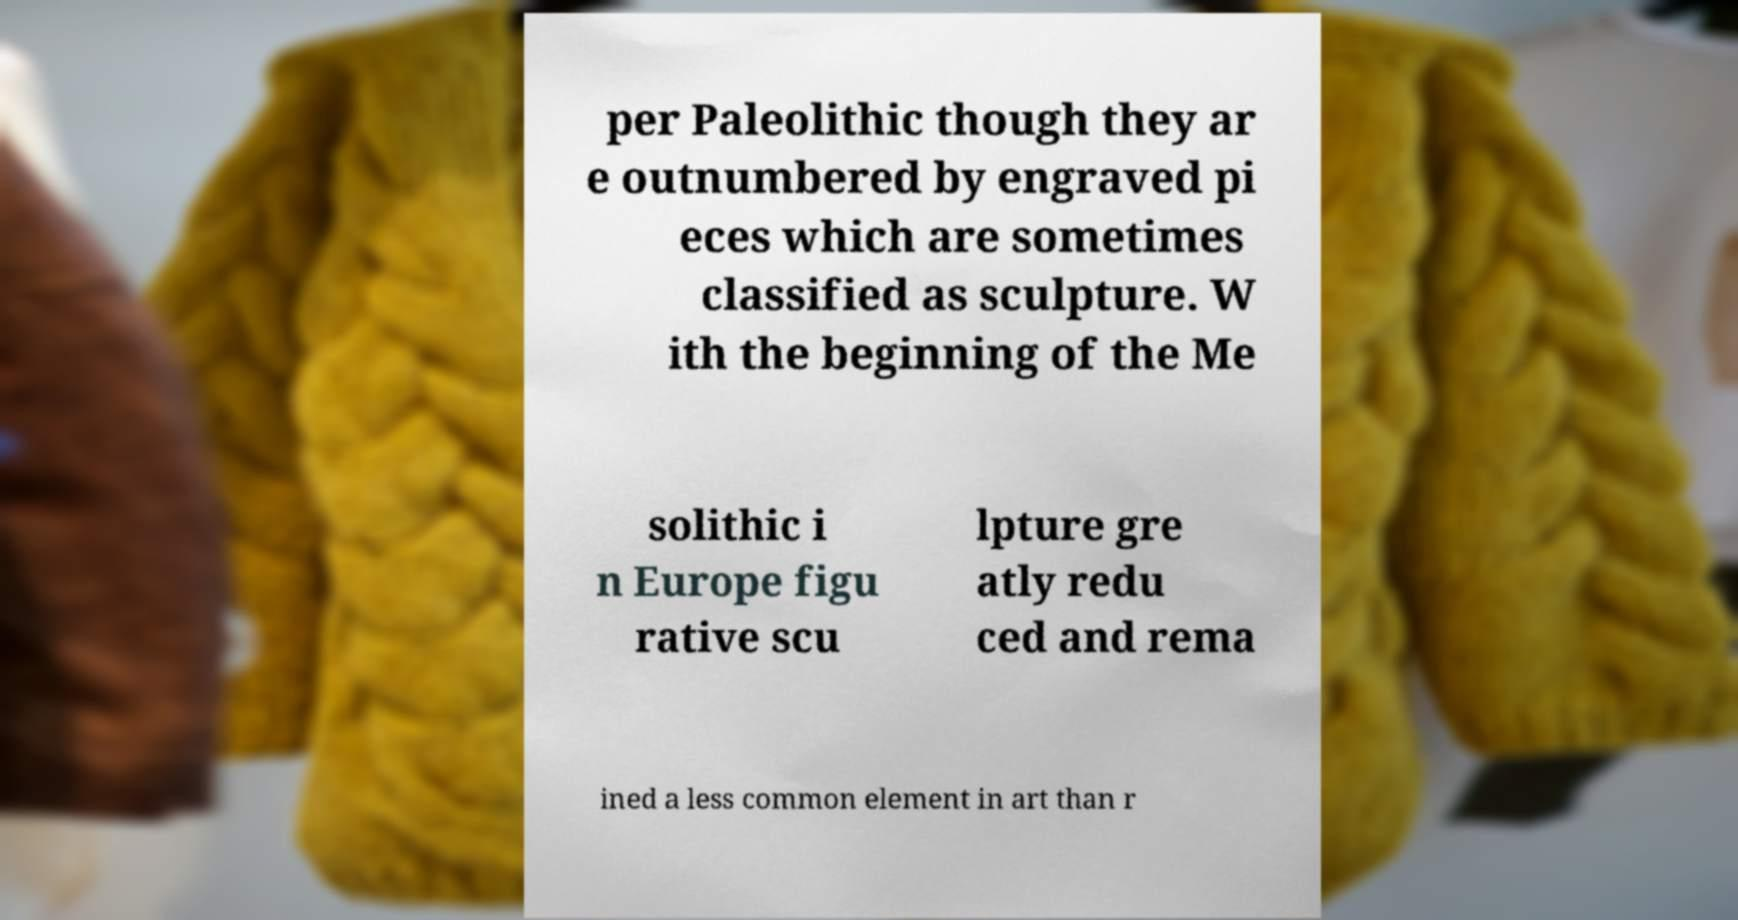Could you extract and type out the text from this image? per Paleolithic though they ar e outnumbered by engraved pi eces which are sometimes classified as sculpture. W ith the beginning of the Me solithic i n Europe figu rative scu lpture gre atly redu ced and rema ined a less common element in art than r 